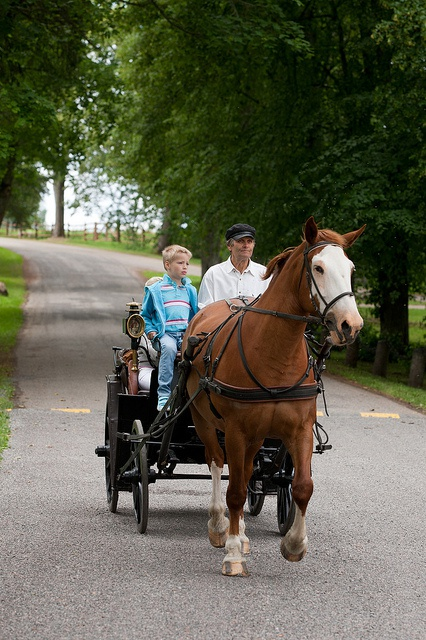Describe the objects in this image and their specific colors. I can see horse in black, maroon, and darkgray tones, people in black, lightblue, gray, and blue tones, and people in black, lightgray, brown, and gray tones in this image. 